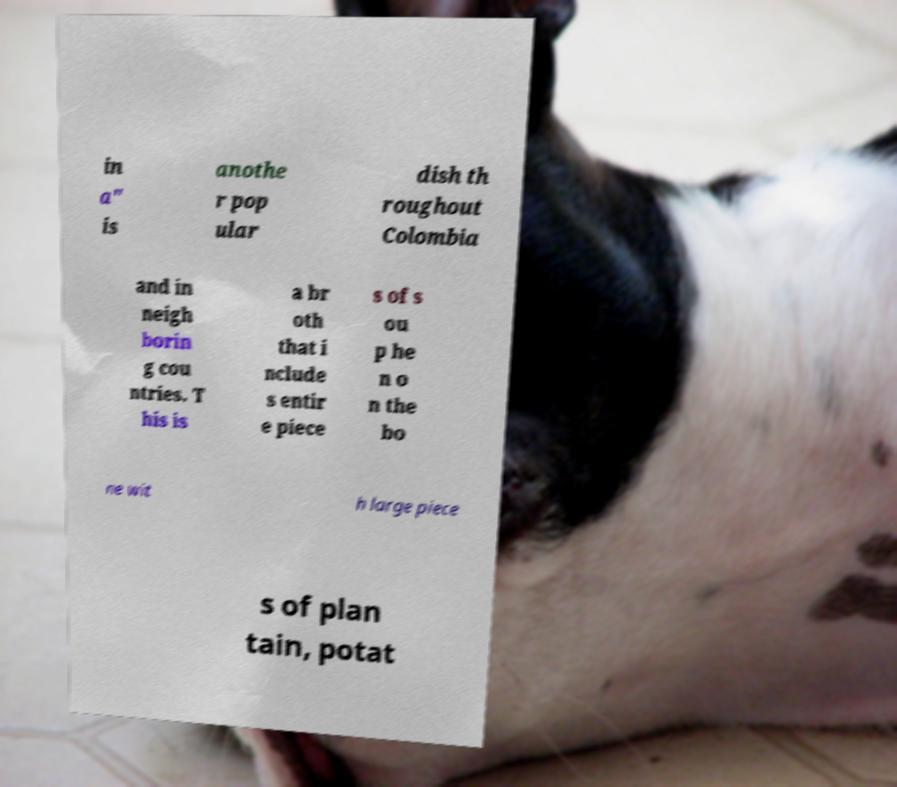Could you extract and type out the text from this image? in a" is anothe r pop ular dish th roughout Colombia and in neigh borin g cou ntries. T his is a br oth that i nclude s entir e piece s of s ou p he n o n the bo ne wit h large piece s of plan tain, potat 